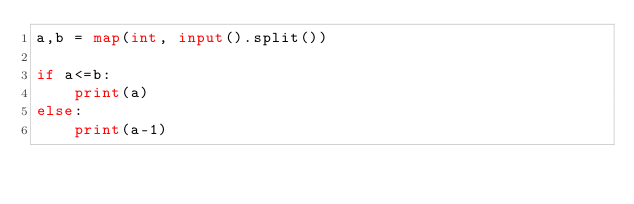<code> <loc_0><loc_0><loc_500><loc_500><_Python_>a,b = map(int, input().split())

if a<=b:
    print(a)
else:
    print(a-1)</code> 